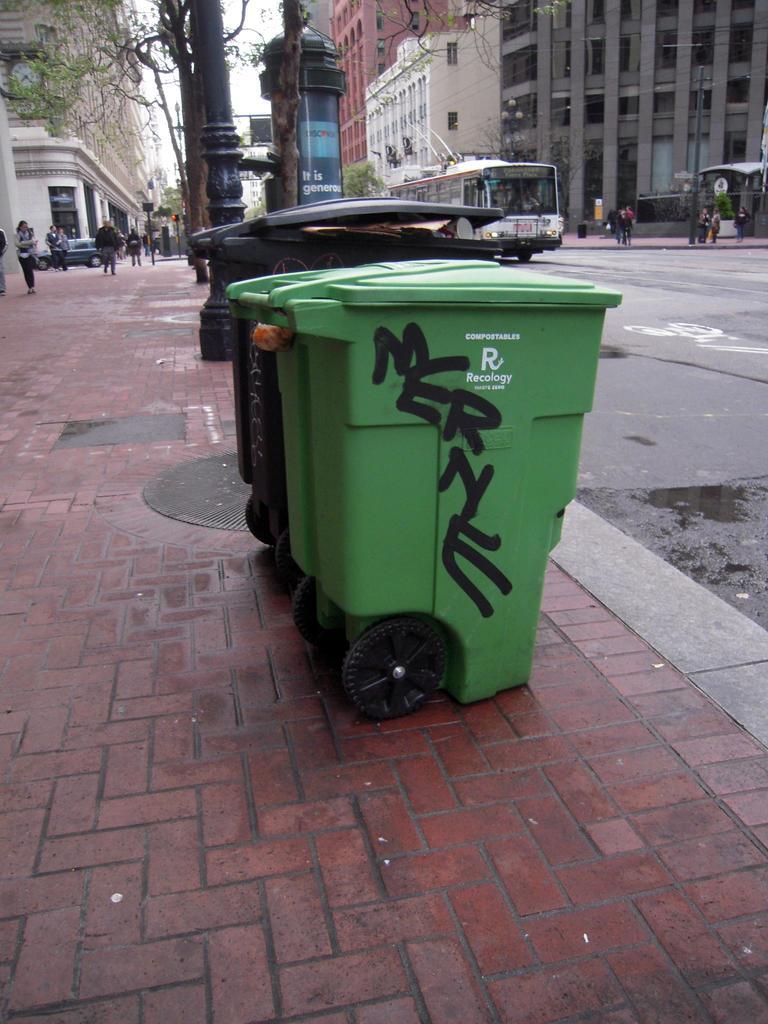What graffiti is written on the bin?
Your answer should be very brief. Merne. 